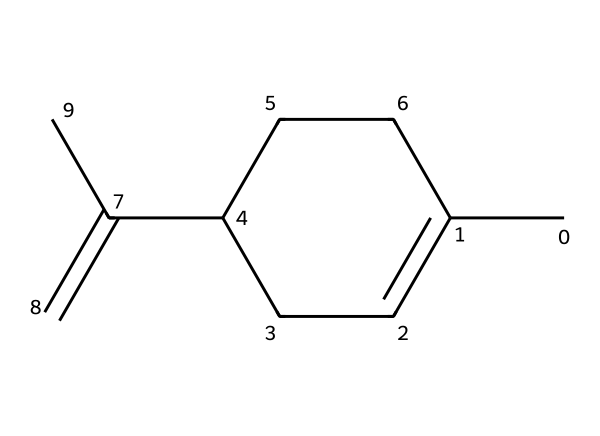What is the molecular formula of limonene? To find the molecular formula, count the number of each type of atom in the structure: there are 10 carbon atoms (C) and 16 hydrogen atoms (H). Therefore, the molecular formula is C10H16.
Answer: C10H16 How many chiral centers are in limonene? A chiral center typically has four different substituents attached to it. In the provided structure, there is one carbon atom at the chiral center which has four different groups attached: a methyl group, an ethylene group, and two different hydrogen atoms. Thus it has one chiral center.
Answer: 1 What type of isomerism does limonene exhibit due to its chiral center? The presence of a chiral center leads to optical isomerism, which means the molecule can exist in two enantiomeric forms that are non-superimposable mirror images of each other.
Answer: optical isomerism What is the significance of limonene's chirality in taste and smell? The chirality of limonene results in two different enantiomers, which can have distinctly different flavors and aromas. For instance, one enantiomer can smell like oranges while the other can smell like lemons, showing how chirality affects sensory perception.
Answer: different flavors What type of compound is limonene classified as? Limonene is classified as a monoterpene, which is a type of terpenoid that consists of two isoprene units, leading to its classification based on its structure.
Answer: monoterpene How many double bonds are present in limonene's structure? By analyzing the structure, we can see there are two double bonds in limonene. Count the instances where carbon atoms are double bonded to each other in the structure.
Answer: 2 